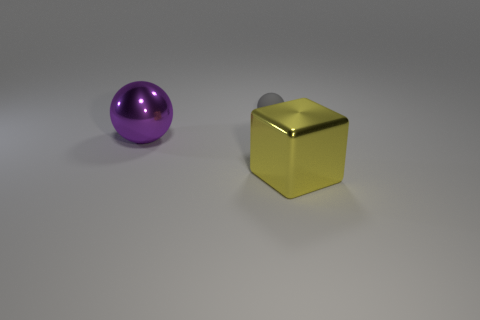Is there any other thing that is made of the same material as the small gray thing?
Provide a succinct answer. No. What color is the large shiny object on the left side of the thing in front of the big purple ball?
Provide a succinct answer. Purple. How many other objects are the same color as the block?
Provide a short and direct response. 0. What is the size of the gray rubber ball?
Your answer should be very brief. Small. Is the number of shiny blocks in front of the metallic sphere greater than the number of big blocks behind the tiny rubber ball?
Offer a terse response. Yes. There is a big object that is to the left of the tiny matte object; what number of tiny gray things are in front of it?
Your answer should be compact. 0. Does the big shiny thing that is on the right side of the large purple shiny thing have the same shape as the purple metal thing?
Your answer should be very brief. No. There is a large object that is the same shape as the tiny gray object; what material is it?
Provide a succinct answer. Metal. How many purple metallic balls have the same size as the yellow metallic cube?
Offer a very short reply. 1. There is a thing that is on the right side of the large ball and behind the big yellow cube; what color is it?
Ensure brevity in your answer.  Gray. 